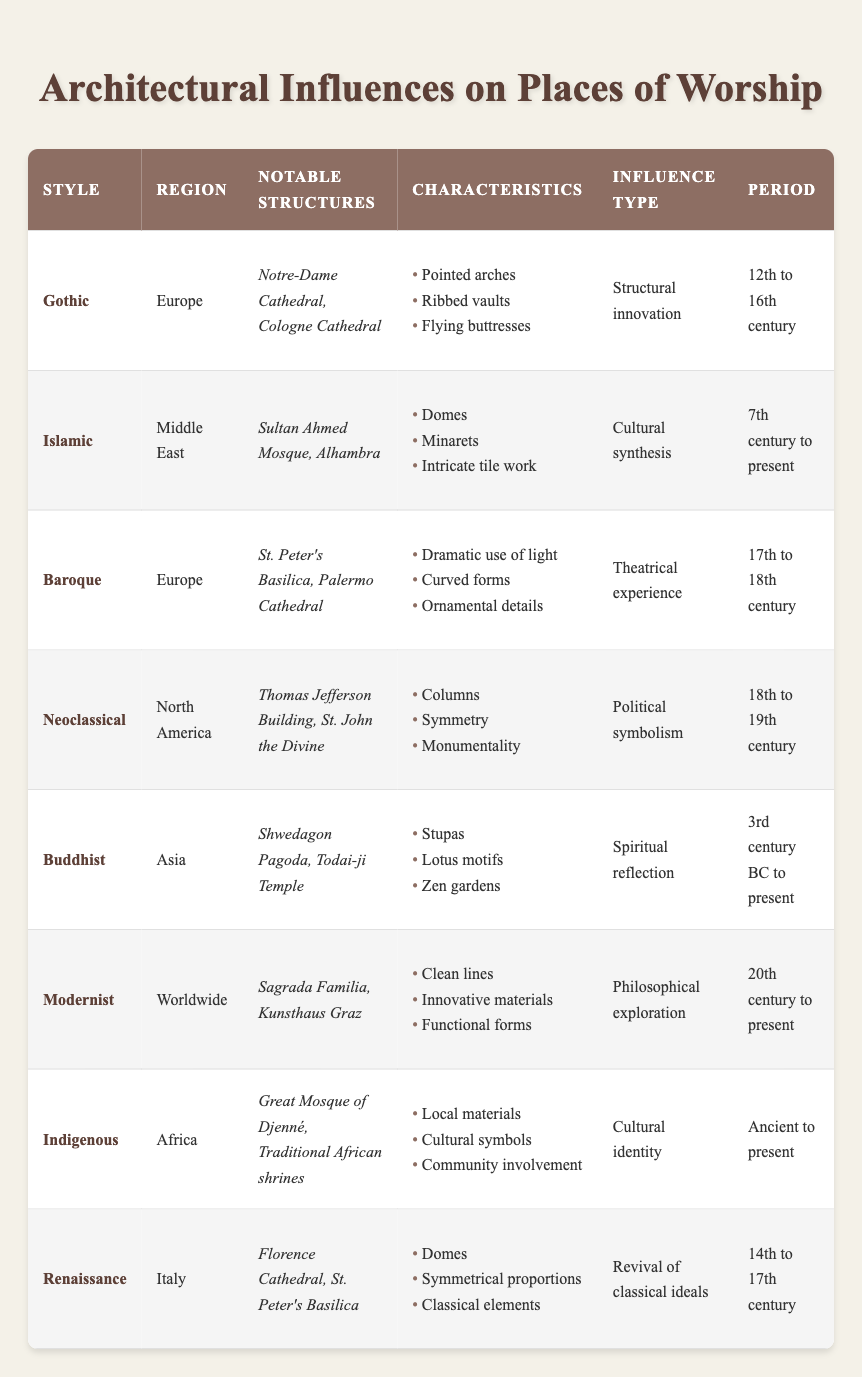What style is associated with pointed arches and ribbed vaults? The Gothic architectural style features characteristics such as pointed arches and ribbed vaults, as indicated in the table.
Answer: Gothic Which region is known for the Renaissance architectural style? According to the table, the Renaissance architectural style is associated with Italy.
Answer: Italy Is the Alhambra a notable structure of the Baroque style? The Alhambra is listed in the table as a notable structure under the Islamic architectural style, not Baroque, therefore this statement is false.
Answer: No What influence type is linked to the Neoclassical style? The table shows that the Neoclassical style is associated with "Political symbolism" as its influence type.
Answer: Political symbolism Which architectural style spans from the 7th century to the present? The Islamic architectural style is noted in the table as spanning from the 7th century to present, which confirms this period.
Answer: Islamic How many architectural styles listed in the table originate from Europe? The table indicates that there are three architectural styles originating from Europe: Gothic, Baroque, and Renaissance. So, adding them gives 3 styles.
Answer: 3 Does the Modernist style include characteristics such as curved forms? The characteristics listed under the Modernist style are "Clean lines, Innovative materials, Functional forms," and do not include curved forms, making this statement false.
Answer: No Which notable structure is associated with the Buddhist style? The Shwedagon Pagoda is listed in the table as a notable structure under the Buddhist architectural style.
Answer: Shwedagon Pagoda What is the average period range for the architectural styles listed in the table? The periods for each style are: Gothic (12th to 16th century), Islamic (7th century to present), Baroque (17th to 18th century), Neoclassical (18th to 19th century), Buddhist (3rd century BC to present), Modernist (20th century to present), Indigenous (Ancient to present), and Renaissance (14th to 17th century). When taking into account the earliest and latest periods, the average period range covers centuries across several millennia, thus the average cannot be precisely determined just from the specific century listings without more calculation.
Answer: Indeterminate 